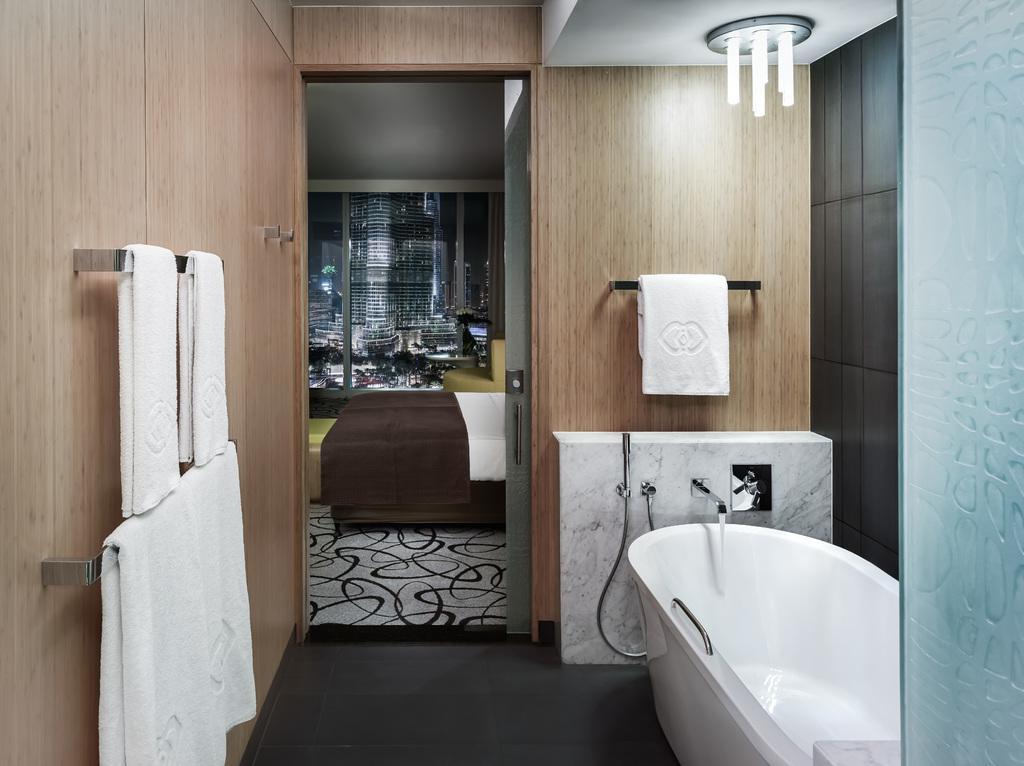How would you summarize this image in a sentence or two? In the image I can see a white color bath tub, taps, towels and some other objects attached to wooden walls. In the background I can see buildings, framed glass wall and some other objects on the floor. 